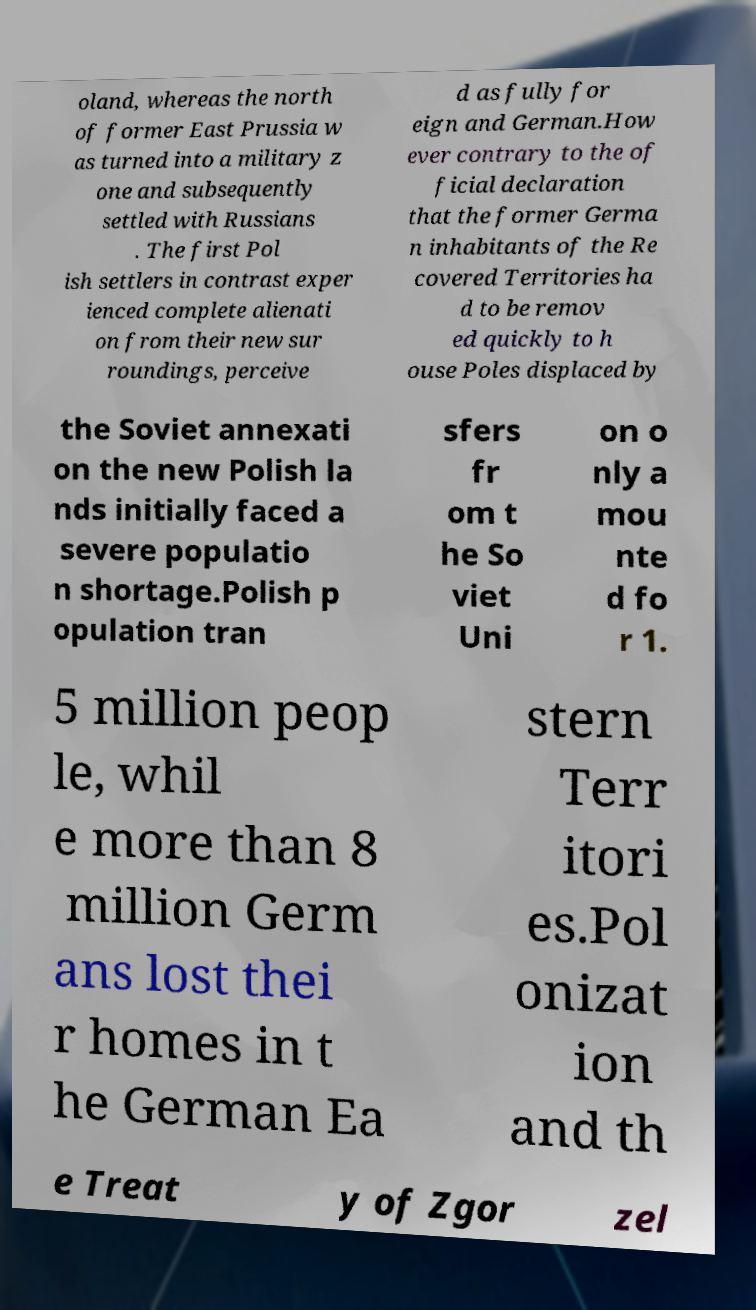What messages or text are displayed in this image? I need them in a readable, typed format. oland, whereas the north of former East Prussia w as turned into a military z one and subsequently settled with Russians . The first Pol ish settlers in contrast exper ienced complete alienati on from their new sur roundings, perceive d as fully for eign and German.How ever contrary to the of ficial declaration that the former Germa n inhabitants of the Re covered Territories ha d to be remov ed quickly to h ouse Poles displaced by the Soviet annexati on the new Polish la nds initially faced a severe populatio n shortage.Polish p opulation tran sfers fr om t he So viet Uni on o nly a mou nte d fo r 1. 5 million peop le, whil e more than 8 million Germ ans lost thei r homes in t he German Ea stern Terr itori es.Pol onizat ion and th e Treat y of Zgor zel 